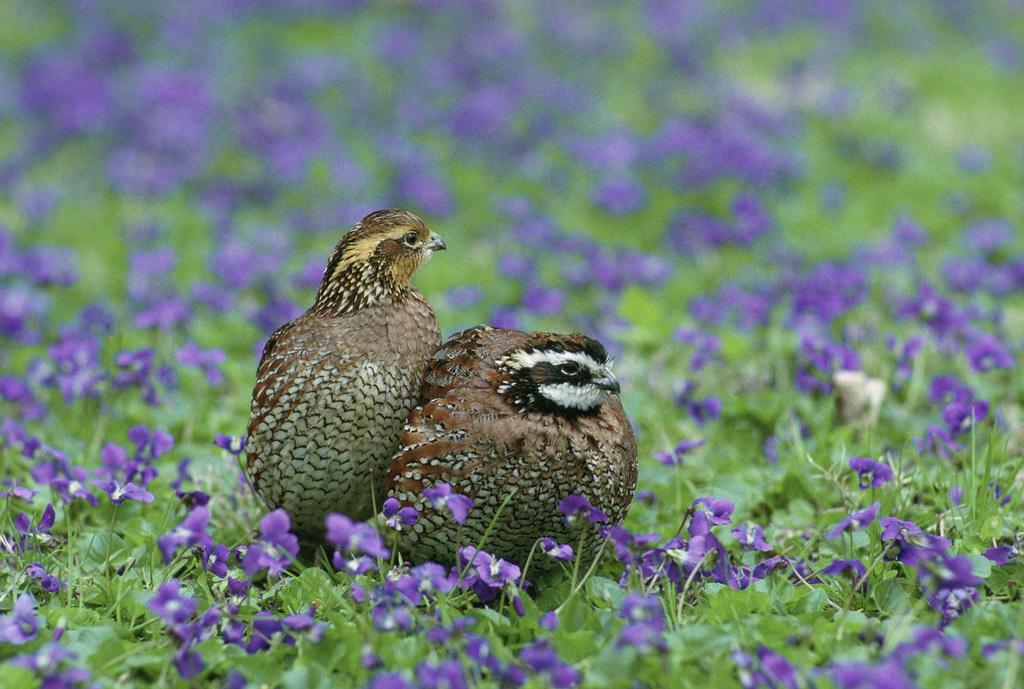What type of living organisms can be seen in the image? Plants and birds are visible in the image. Where are the birds located in the image? The birds are in the middle of the image. Can you describe the background of the image? The background of the image is blurred. What type of drug can be seen in the image? There is no drug present in the image; it features plants and birds. Is there an airplane visible in the image? No, there is no airplane present in the image. 